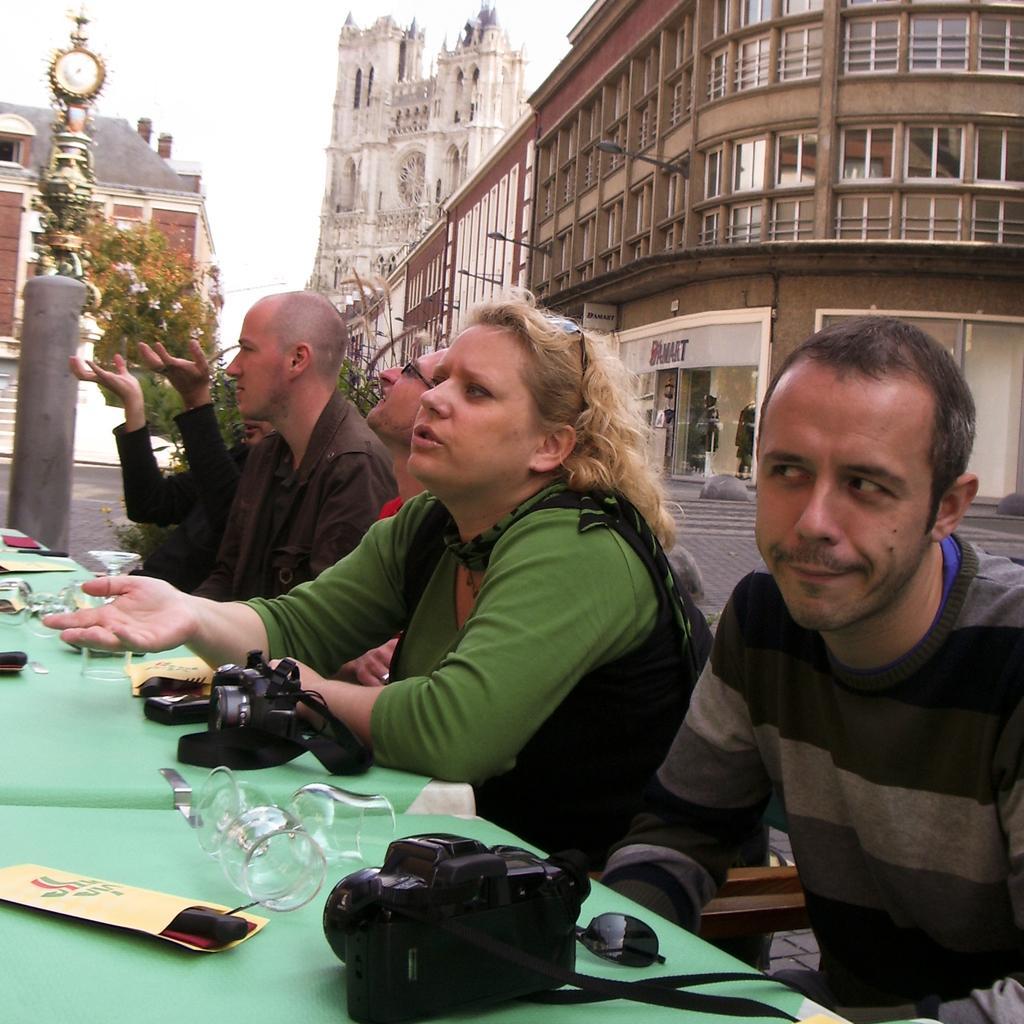Can you describe this image briefly? In the image we can see there are people sitting on the chair and on the table there are cameras, wine glasses and paper slips. Behind there are buildings and there is clock tower. There are trees. 